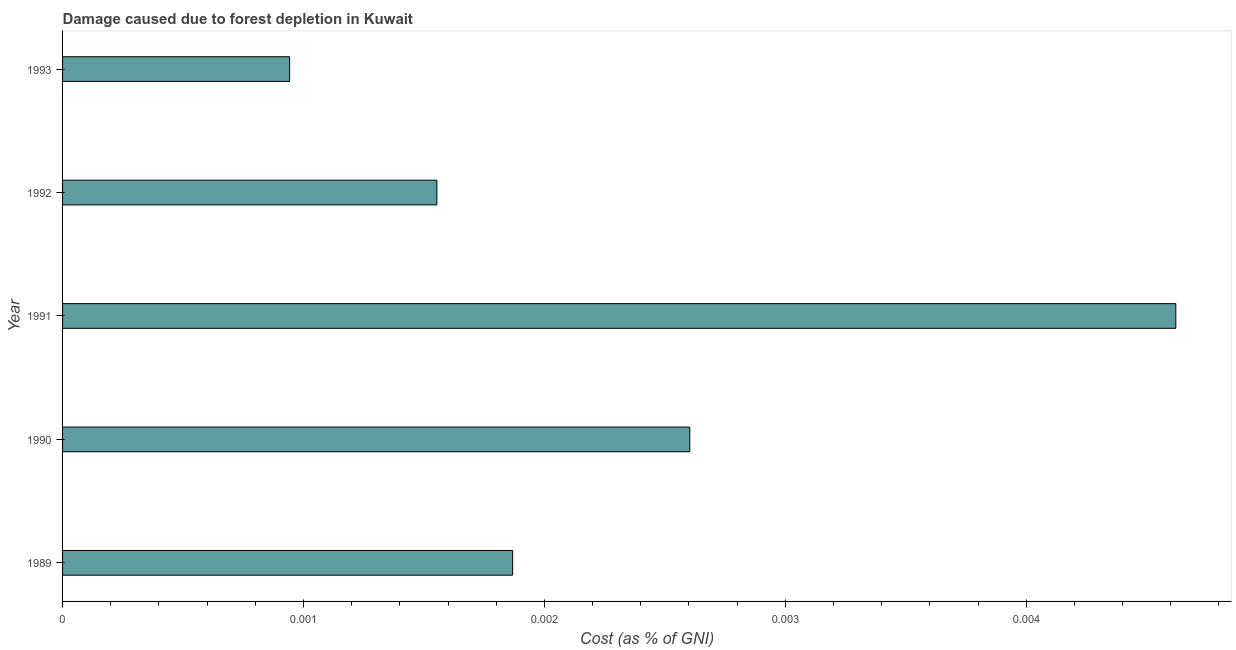Does the graph contain any zero values?
Provide a short and direct response. No. What is the title of the graph?
Keep it short and to the point. Damage caused due to forest depletion in Kuwait. What is the label or title of the X-axis?
Give a very brief answer. Cost (as % of GNI). What is the label or title of the Y-axis?
Make the answer very short. Year. What is the damage caused due to forest depletion in 1992?
Offer a very short reply. 0. Across all years, what is the maximum damage caused due to forest depletion?
Offer a very short reply. 0. Across all years, what is the minimum damage caused due to forest depletion?
Keep it short and to the point. 0. In which year was the damage caused due to forest depletion minimum?
Your answer should be very brief. 1993. What is the sum of the damage caused due to forest depletion?
Your answer should be very brief. 0.01. What is the difference between the damage caused due to forest depletion in 1991 and 1993?
Your response must be concise. 0. What is the average damage caused due to forest depletion per year?
Your answer should be compact. 0. What is the median damage caused due to forest depletion?
Your answer should be compact. 0. What is the ratio of the damage caused due to forest depletion in 1989 to that in 1990?
Make the answer very short. 0.72. What is the difference between the highest and the second highest damage caused due to forest depletion?
Keep it short and to the point. 0. Is the sum of the damage caused due to forest depletion in 1989 and 1992 greater than the maximum damage caused due to forest depletion across all years?
Offer a terse response. No. Are all the bars in the graph horizontal?
Ensure brevity in your answer.  Yes. How many years are there in the graph?
Keep it short and to the point. 5. What is the Cost (as % of GNI) in 1989?
Ensure brevity in your answer.  0. What is the Cost (as % of GNI) in 1990?
Your answer should be very brief. 0. What is the Cost (as % of GNI) of 1991?
Provide a short and direct response. 0. What is the Cost (as % of GNI) of 1992?
Keep it short and to the point. 0. What is the Cost (as % of GNI) in 1993?
Offer a terse response. 0. What is the difference between the Cost (as % of GNI) in 1989 and 1990?
Your answer should be very brief. -0. What is the difference between the Cost (as % of GNI) in 1989 and 1991?
Your response must be concise. -0. What is the difference between the Cost (as % of GNI) in 1989 and 1992?
Offer a very short reply. 0. What is the difference between the Cost (as % of GNI) in 1989 and 1993?
Provide a succinct answer. 0. What is the difference between the Cost (as % of GNI) in 1990 and 1991?
Provide a short and direct response. -0. What is the difference between the Cost (as % of GNI) in 1990 and 1992?
Give a very brief answer. 0. What is the difference between the Cost (as % of GNI) in 1990 and 1993?
Offer a terse response. 0. What is the difference between the Cost (as % of GNI) in 1991 and 1992?
Offer a very short reply. 0. What is the difference between the Cost (as % of GNI) in 1991 and 1993?
Your answer should be very brief. 0. What is the difference between the Cost (as % of GNI) in 1992 and 1993?
Give a very brief answer. 0. What is the ratio of the Cost (as % of GNI) in 1989 to that in 1990?
Ensure brevity in your answer.  0.72. What is the ratio of the Cost (as % of GNI) in 1989 to that in 1991?
Your answer should be very brief. 0.4. What is the ratio of the Cost (as % of GNI) in 1989 to that in 1992?
Provide a succinct answer. 1.2. What is the ratio of the Cost (as % of GNI) in 1989 to that in 1993?
Offer a terse response. 1.98. What is the ratio of the Cost (as % of GNI) in 1990 to that in 1991?
Your answer should be compact. 0.56. What is the ratio of the Cost (as % of GNI) in 1990 to that in 1992?
Your answer should be compact. 1.68. What is the ratio of the Cost (as % of GNI) in 1990 to that in 1993?
Your response must be concise. 2.76. What is the ratio of the Cost (as % of GNI) in 1991 to that in 1992?
Your response must be concise. 2.97. What is the ratio of the Cost (as % of GNI) in 1991 to that in 1993?
Provide a succinct answer. 4.9. What is the ratio of the Cost (as % of GNI) in 1992 to that in 1993?
Offer a very short reply. 1.65. 